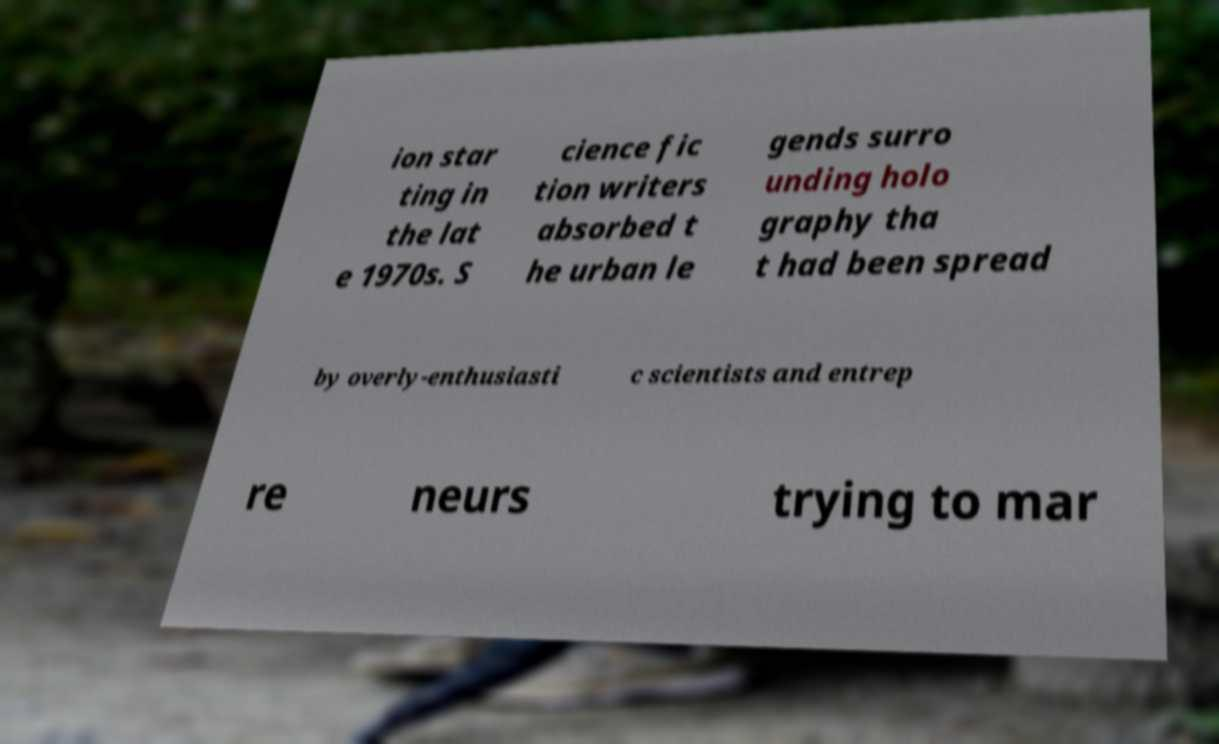For documentation purposes, I need the text within this image transcribed. Could you provide that? ion star ting in the lat e 1970s. S cience fic tion writers absorbed t he urban le gends surro unding holo graphy tha t had been spread by overly-enthusiasti c scientists and entrep re neurs trying to mar 